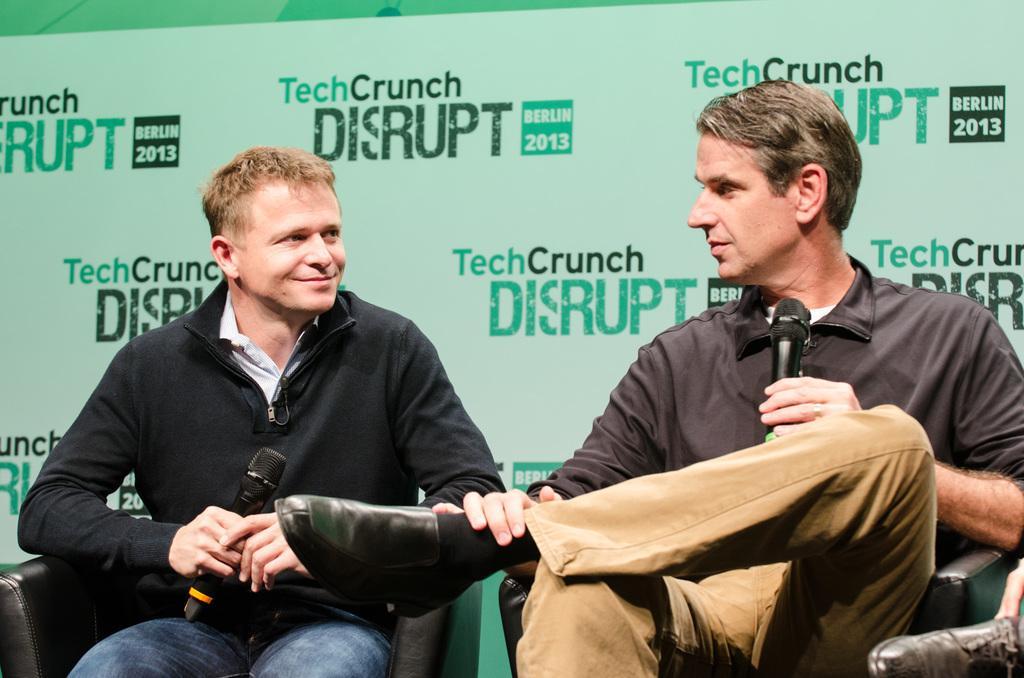Please provide a concise description of this image. In this picture there are two men sitting on chairs and holding microphones. In the background of the image we can see hoarding. 